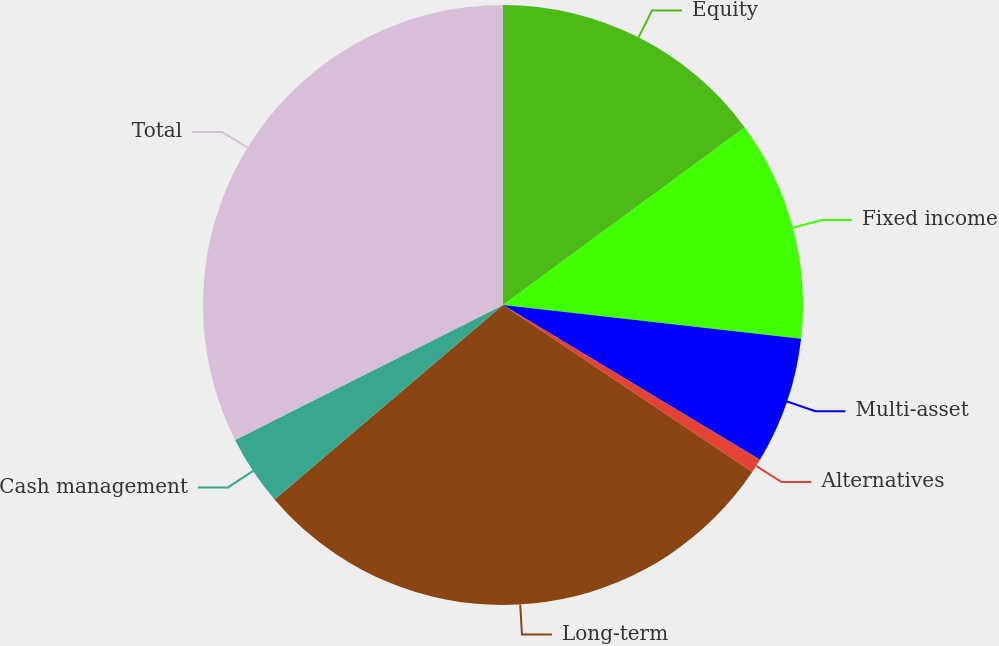Convert chart to OTSL. <chart><loc_0><loc_0><loc_500><loc_500><pie_chart><fcel>Equity<fcel>Fixed income<fcel>Multi-asset<fcel>Alternatives<fcel>Long-term<fcel>Cash management<fcel>Total<nl><fcel>14.92%<fcel>11.88%<fcel>6.84%<fcel>0.76%<fcel>29.39%<fcel>3.8%<fcel>32.43%<nl></chart> 